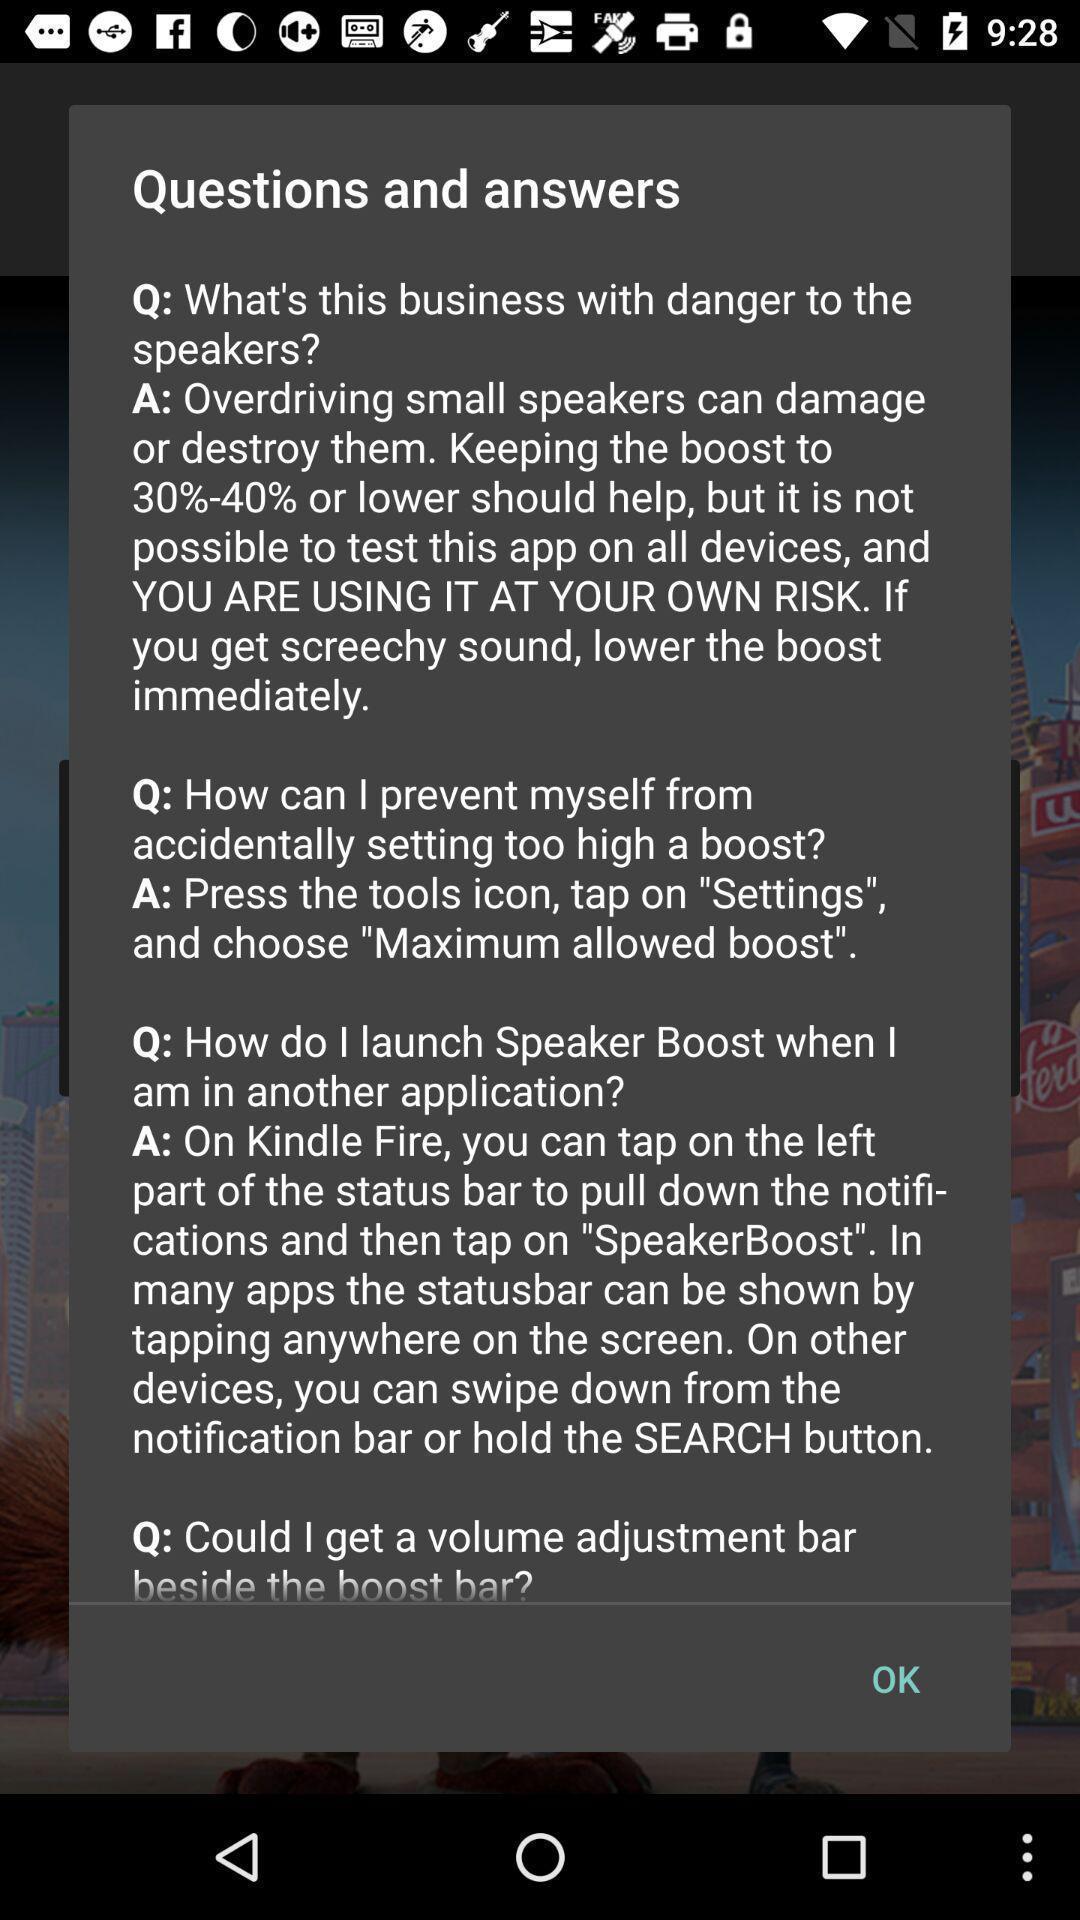Tell me about the visual elements in this screen capture. Popup showing about question and answers. 